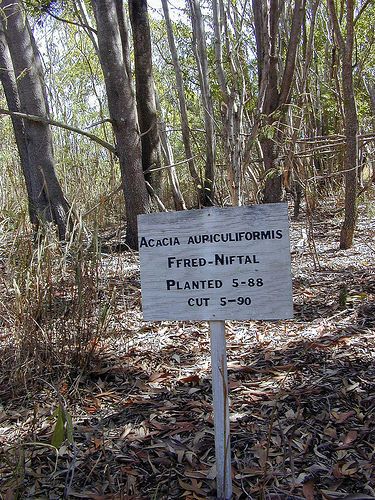<image>
Is the tree next to the sign? No. The tree is not positioned next to the sign. They are located in different areas of the scene. 